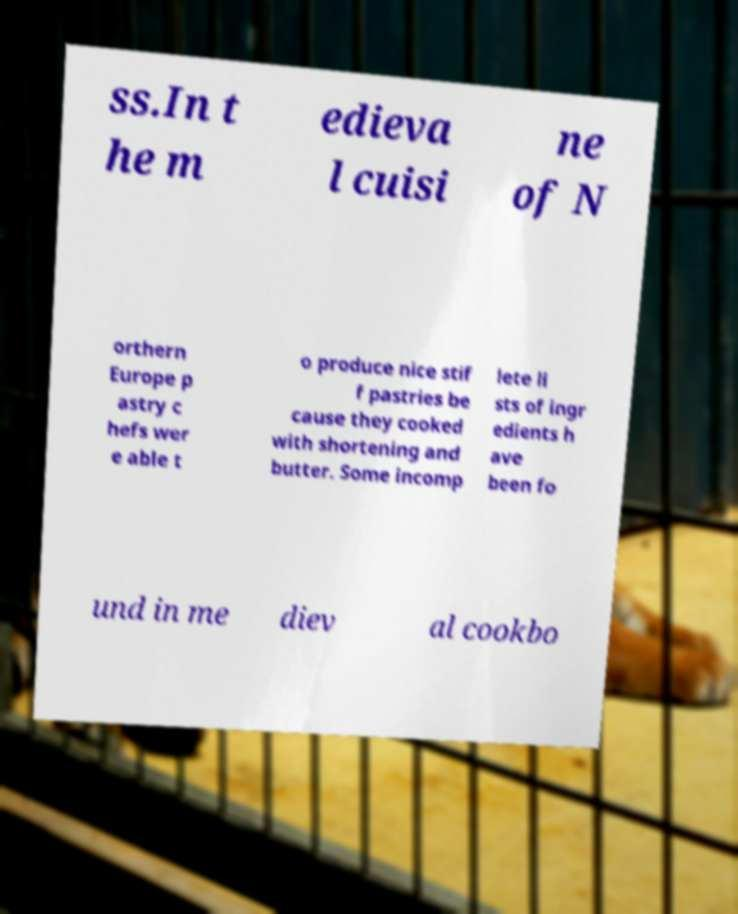Could you assist in decoding the text presented in this image and type it out clearly? ss.In t he m edieva l cuisi ne of N orthern Europe p astry c hefs wer e able t o produce nice stif f pastries be cause they cooked with shortening and butter. Some incomp lete li sts of ingr edients h ave been fo und in me diev al cookbo 